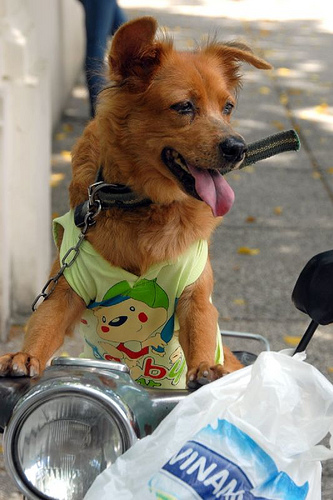Read all the text in this image. b 